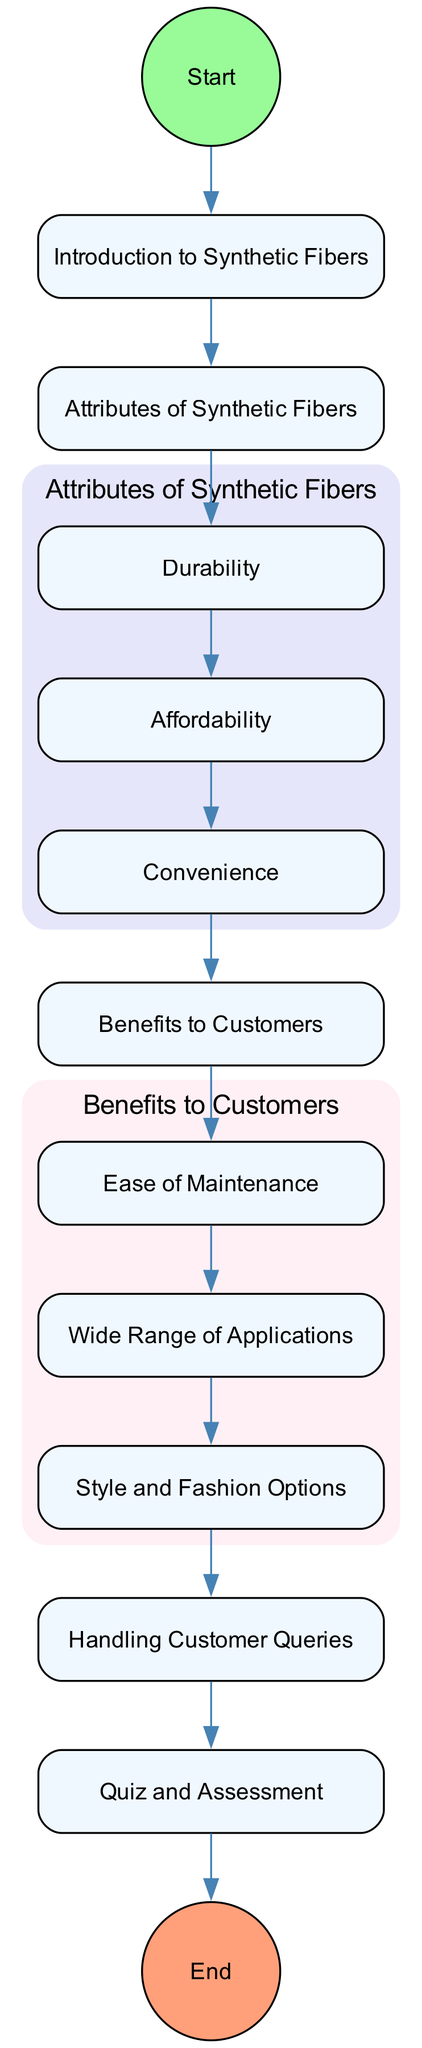What is the first step in the training process? The diagram shows a "Start" node that leads into the first activity, which is "Introduction to Synthetic Fibers." Therefore, the first step is the Introduction.
Answer: Introduction to Synthetic Fibers How many attributes of synthetic fibers are there? The diagram lists three specific attributes: Durability, Affordability, and Convenience. By counting these, I find there are three attributes in total.
Answer: Three What is the last activity before the assessment quiz? The last activity shown before reaching the "Quiz and Assessment" node is "Handling Customer Queries." This indicates that employees handle customer queries before the assessment.
Answer: Handling Customer Queries Which node leads to customer benefits? From "Attributes of Synthetic Fibers," the path leads to the node "Benefits to Customers." It shows that understanding the attributes leads directly into discussing the benefits.
Answer: Benefits to Customers What are two benefits of synthetic fibers according to the diagram? The diagram lists three benefits: Ease of Maintenance, Wide Range of Applications, and Style and Fashion Options. Two of these can be any combination of the listed benefits, such as Ease of Maintenance and Style and Fashion Options.
Answer: Ease of Maintenance, Style and Fashion Options What is the type of the final node in the diagram? The final node is labeled "End," which indicates that it is categorized as an end event in the flowchart, indicating the conclusion of the training.
Answer: End 